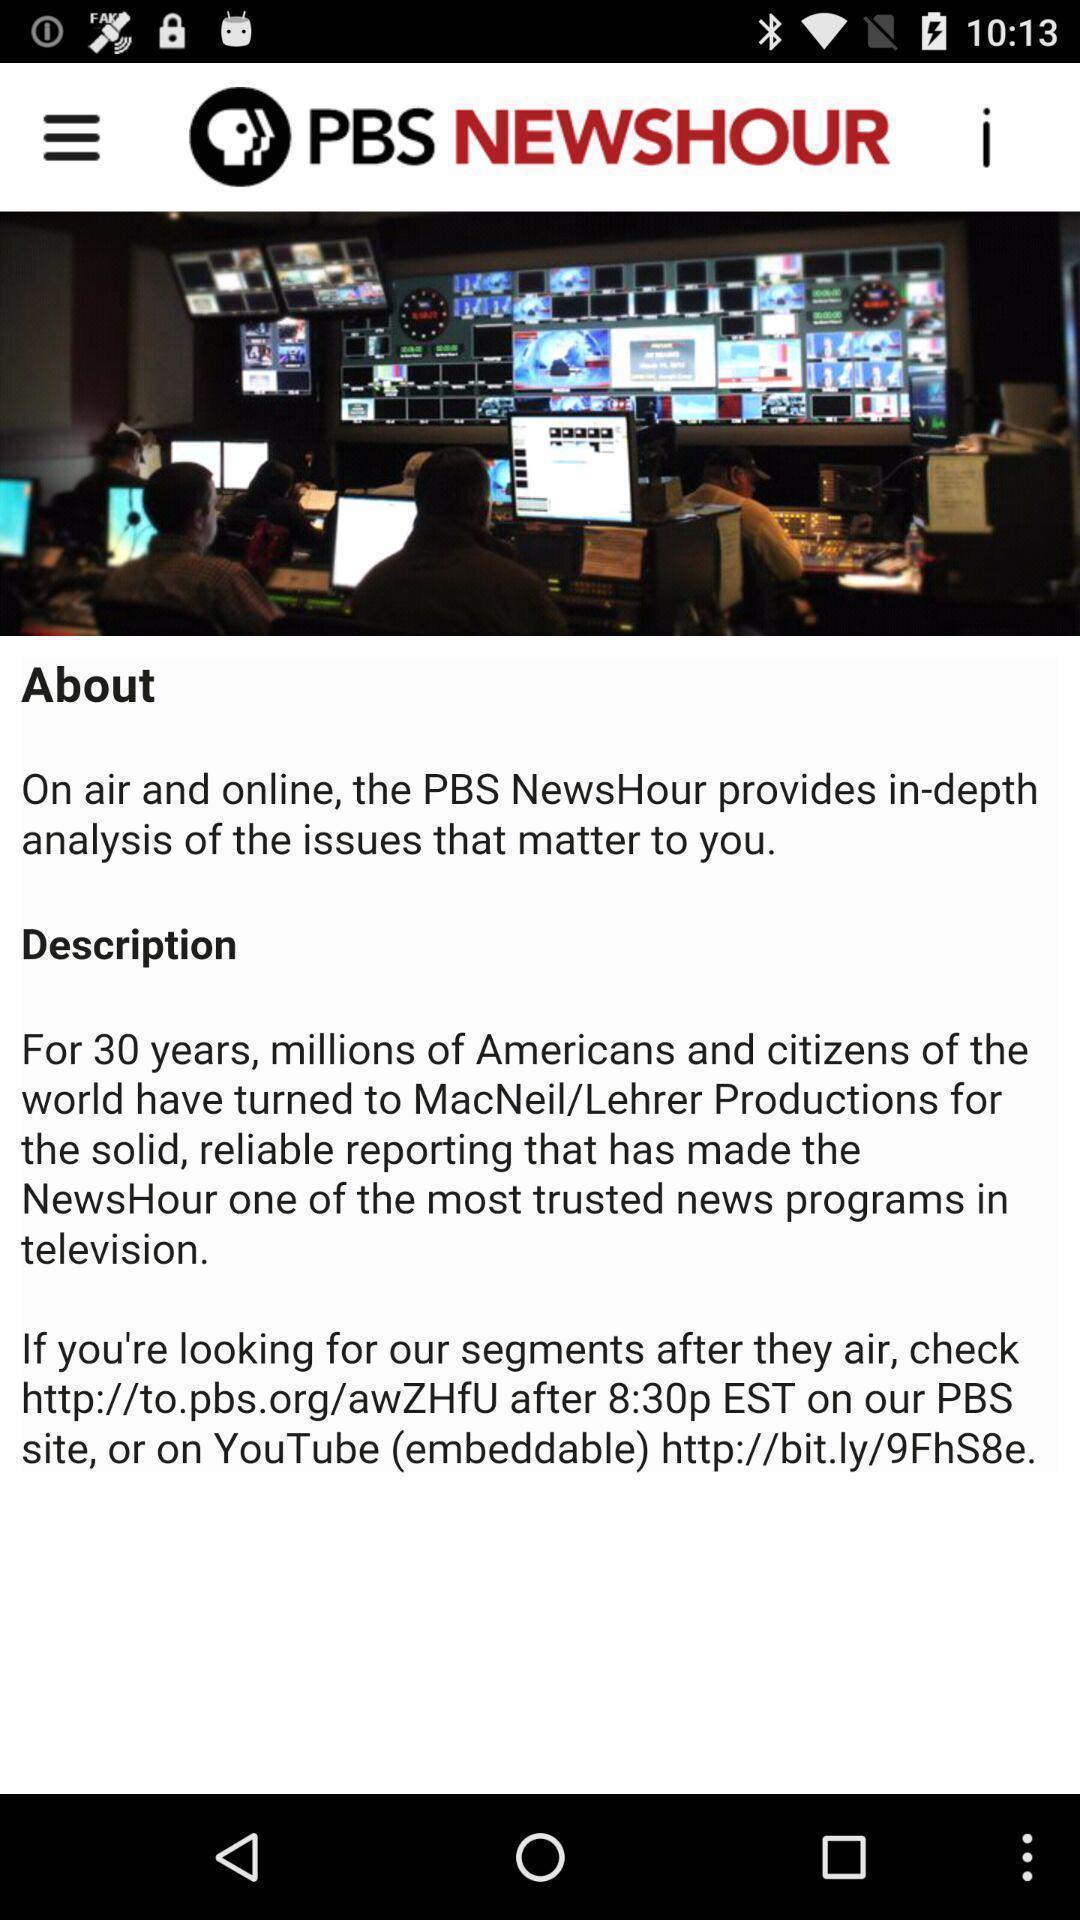Summarize the information in this screenshot. Screen showing description page of a news app. 